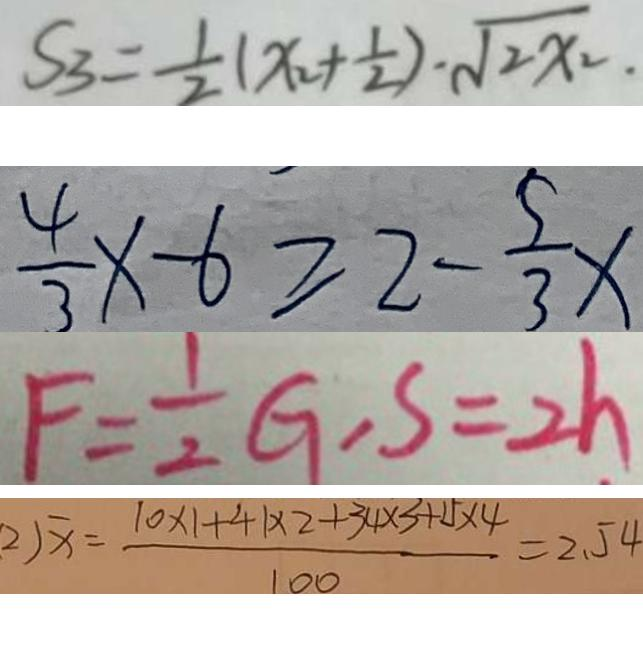Convert formula to latex. <formula><loc_0><loc_0><loc_500><loc_500>S _ { 3 } = \frac { 1 } { 2 } ( x _ { 2 } + \frac { 1 } { 2 } ) \cdot \sqrt { 2 x _ { 2 } . } 
 \frac { 4 } { 3 } x - 6 \geq 2 - \frac { 5 } { 3 } x 
 F = \frac { 1 } { 2 } G , S = 2 h 
 2 \sqrt { x } = \frac { 1 0 \times 1 + 4 + 1 \times 2 + 3 4 \times 3 + 1 5 \times 4 } { 1 0 0 } = 2 . 5 4</formula> 